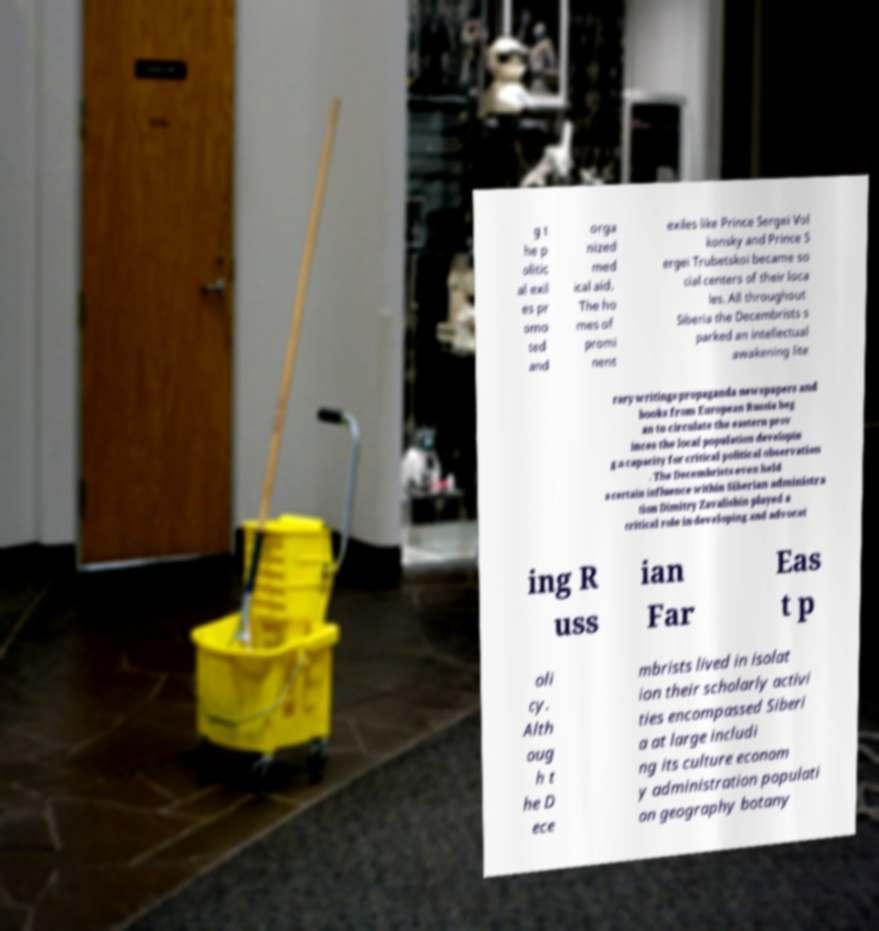Can you accurately transcribe the text from the provided image for me? g t he p olitic al exil es pr omo ted and orga nized med ical aid. The ho mes of promi nent exiles like Prince Sergei Vol konsky and Prince S ergei Trubetskoi became so cial centers of their loca les. All throughout Siberia the Decembrists s parked an intellectual awakening lite rary writings propaganda newspapers and books from European Russia beg an to circulate the eastern prov inces the local population developin g a capacity for critical political observation . The Decembrists even held a certain influence within Siberian administra tion Dimitry Zavalishin played a critical role in developing and advocat ing R uss ian Far Eas t p oli cy. Alth oug h t he D ece mbrists lived in isolat ion their scholarly activi ties encompassed Siberi a at large includi ng its culture econom y administration populati on geography botany 